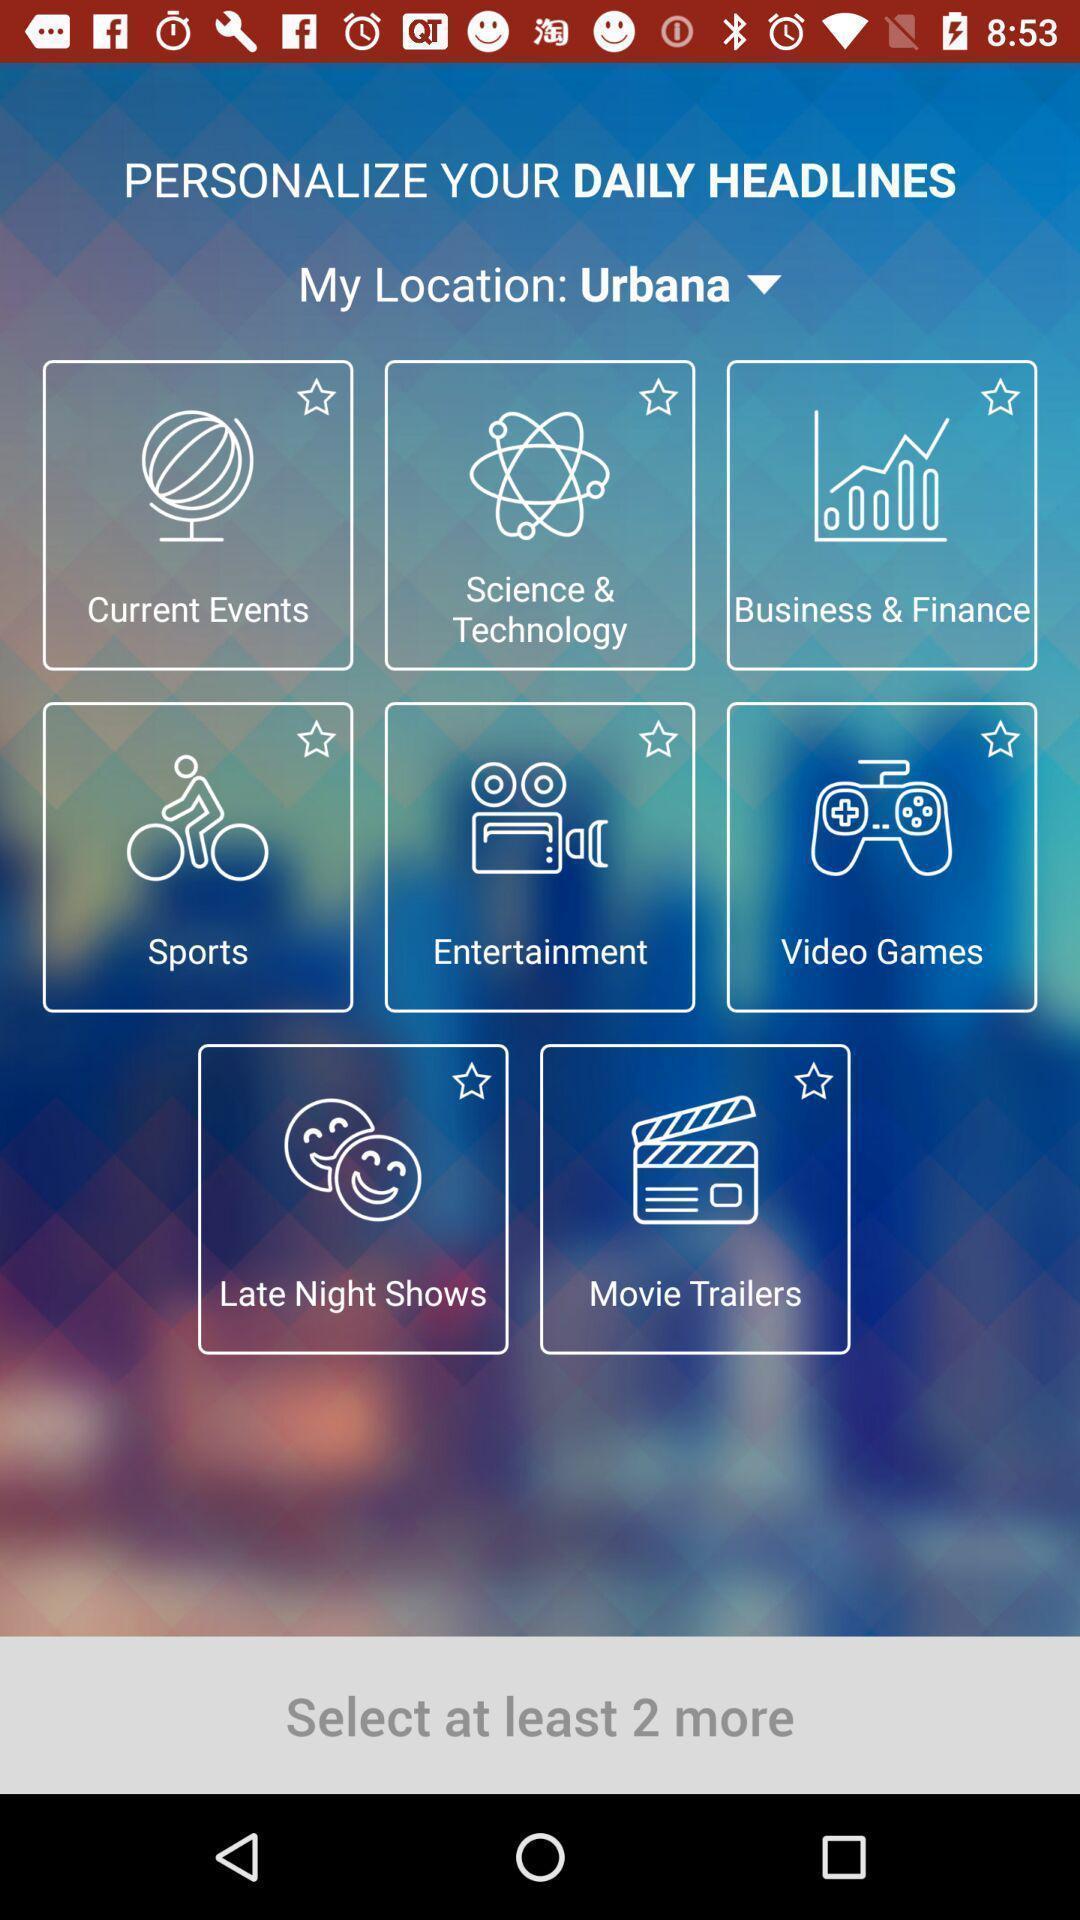Describe the key features of this screenshot. Page displays various categories in app. 